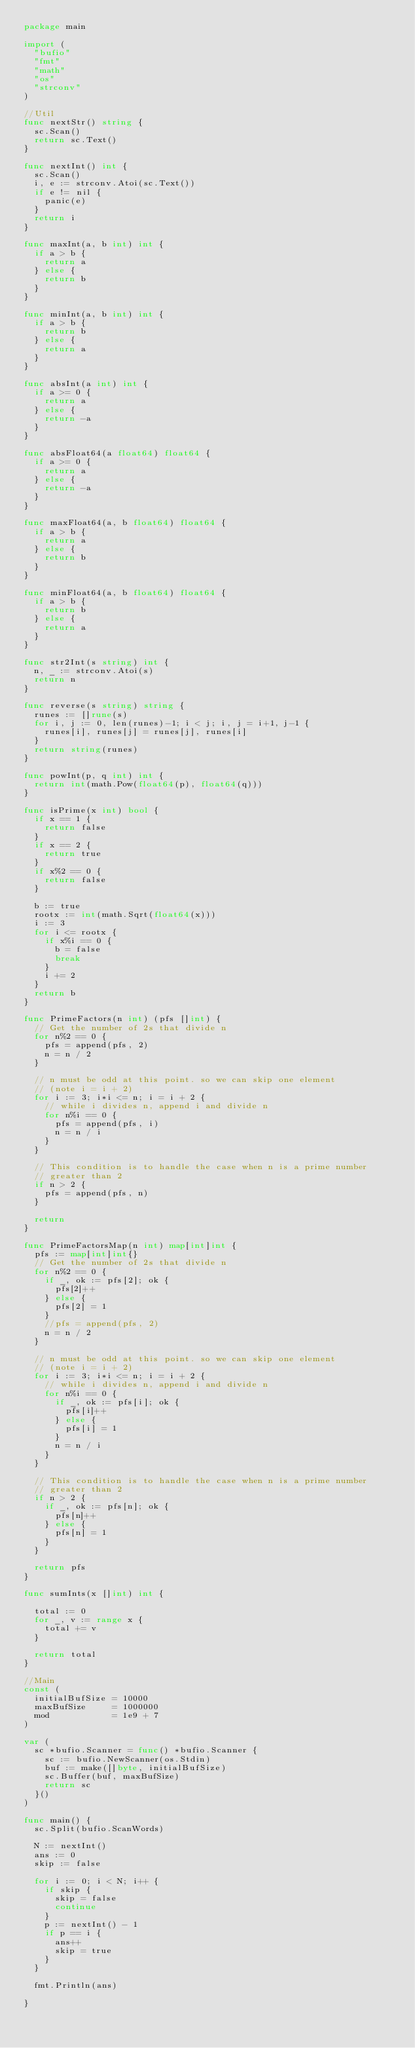Convert code to text. <code><loc_0><loc_0><loc_500><loc_500><_Go_>package main

import (
	"bufio"
	"fmt"
	"math"
	"os"
	"strconv"
)

//Util
func nextStr() string {
	sc.Scan()
	return sc.Text()
}

func nextInt() int {
	sc.Scan()
	i, e := strconv.Atoi(sc.Text())
	if e != nil {
		panic(e)
	}
	return i
}

func maxInt(a, b int) int {
	if a > b {
		return a
	} else {
		return b
	}
}

func minInt(a, b int) int {
	if a > b {
		return b
	} else {
		return a
	}
}

func absInt(a int) int {
	if a >= 0 {
		return a
	} else {
		return -a
	}
}

func absFloat64(a float64) float64 {
	if a >= 0 {
		return a
	} else {
		return -a
	}
}

func maxFloat64(a, b float64) float64 {
	if a > b {
		return a
	} else {
		return b
	}
}

func minFloat64(a, b float64) float64 {
	if a > b {
		return b
	} else {
		return a
	}
}

func str2Int(s string) int {
	n, _ := strconv.Atoi(s)
	return n
}

func reverse(s string) string {
	runes := []rune(s)
	for i, j := 0, len(runes)-1; i < j; i, j = i+1, j-1 {
		runes[i], runes[j] = runes[j], runes[i]
	}
	return string(runes)
}

func powInt(p, q int) int {
	return int(math.Pow(float64(p), float64(q)))
}

func isPrime(x int) bool {
	if x == 1 {
		return false
	}
	if x == 2 {
		return true
	}
	if x%2 == 0 {
		return false
	}

	b := true
	rootx := int(math.Sqrt(float64(x)))
	i := 3
	for i <= rootx {
		if x%i == 0 {
			b = false
			break
		}
		i += 2
	}
	return b
}

func PrimeFactors(n int) (pfs []int) {
	// Get the number of 2s that divide n
	for n%2 == 0 {
		pfs = append(pfs, 2)
		n = n / 2
	}

	// n must be odd at this point. so we can skip one element
	// (note i = i + 2)
	for i := 3; i*i <= n; i = i + 2 {
		// while i divides n, append i and divide n
		for n%i == 0 {
			pfs = append(pfs, i)
			n = n / i
		}
	}

	// This condition is to handle the case when n is a prime number
	// greater than 2
	if n > 2 {
		pfs = append(pfs, n)
	}

	return
}

func PrimeFactorsMap(n int) map[int]int {
	pfs := map[int]int{}
	// Get the number of 2s that divide n
	for n%2 == 0 {
		if _, ok := pfs[2]; ok {
			pfs[2]++
		} else {
			pfs[2] = 1
		}
		//pfs = append(pfs, 2)
		n = n / 2
	}

	// n must be odd at this point. so we can skip one element
	// (note i = i + 2)
	for i := 3; i*i <= n; i = i + 2 {
		// while i divides n, append i and divide n
		for n%i == 0 {
			if _, ok := pfs[i]; ok {
				pfs[i]++
			} else {
				pfs[i] = 1
			}
			n = n / i
		}
	}

	// This condition is to handle the case when n is a prime number
	// greater than 2
	if n > 2 {
		if _, ok := pfs[n]; ok {
			pfs[n]++
		} else {
			pfs[n] = 1
		}
	}

	return pfs
}

func sumInts(x []int) int {

	total := 0
	for _, v := range x {
		total += v
	}

	return total
}

//Main
const (
	initialBufSize = 10000
	maxBufSize     = 1000000
	mod            = 1e9 + 7
)

var (
	sc *bufio.Scanner = func() *bufio.Scanner {
		sc := bufio.NewScanner(os.Stdin)
		buf := make([]byte, initialBufSize)
		sc.Buffer(buf, maxBufSize)
		return sc
	}()
)

func main() {
	sc.Split(bufio.ScanWords)

	N := nextInt()
	ans := 0
	skip := false

	for i := 0; i < N; i++ {
		if skip {
			skip = false
			continue
		}
		p := nextInt() - 1
		if p == i {
			ans++
			skip = true
		}
	}

	fmt.Println(ans)

}
</code> 